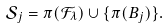Convert formula to latex. <formula><loc_0><loc_0><loc_500><loc_500>\mathcal { S } _ { j } = \pi ( \mathcal { F } _ { \lambda } ) \cup \{ \pi ( B _ { j } ) \} .</formula> 